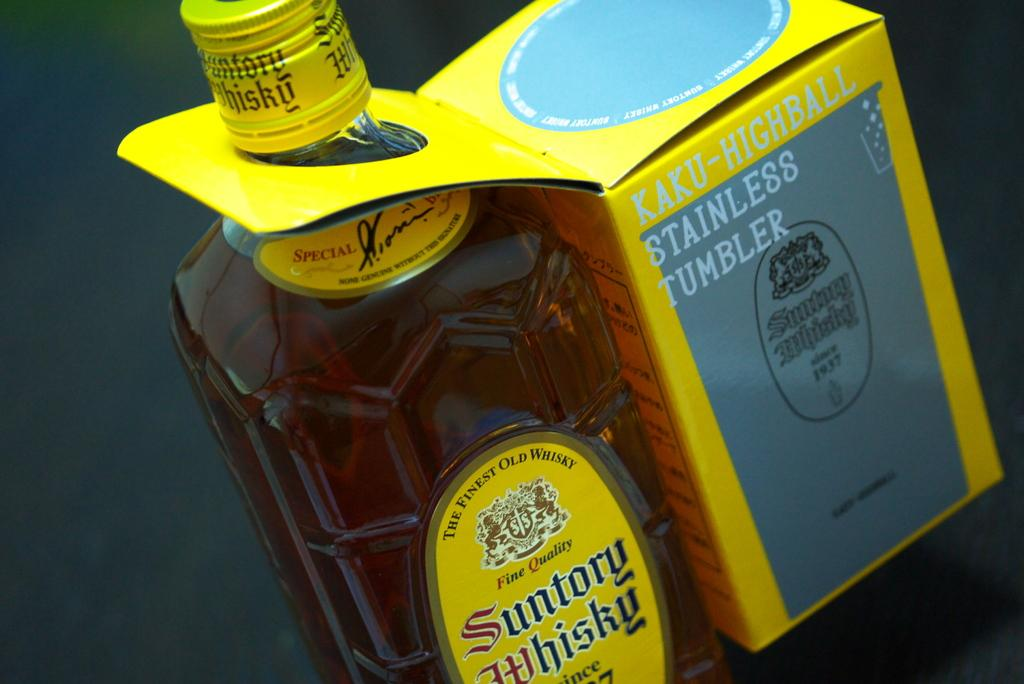Provide a one-sentence caption for the provided image. A bottle of whiskey with a stainless steel tumbler attached as an extra. 